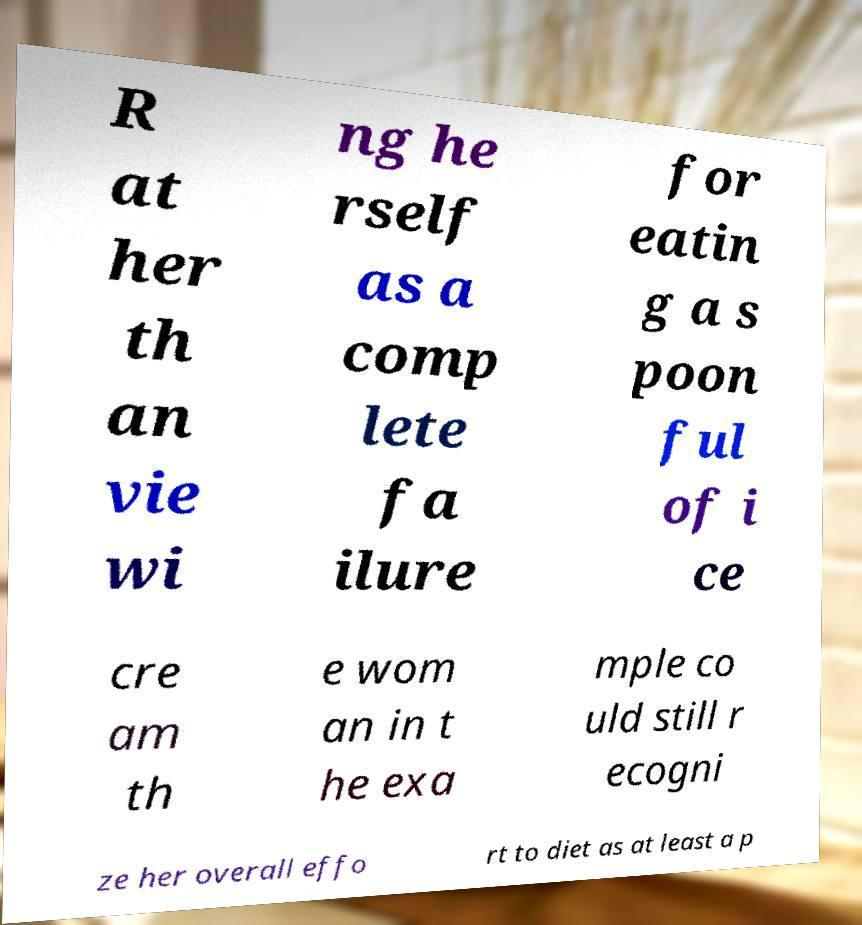Can you read and provide the text displayed in the image?This photo seems to have some interesting text. Can you extract and type it out for me? R at her th an vie wi ng he rself as a comp lete fa ilure for eatin g a s poon ful of i ce cre am th e wom an in t he exa mple co uld still r ecogni ze her overall effo rt to diet as at least a p 